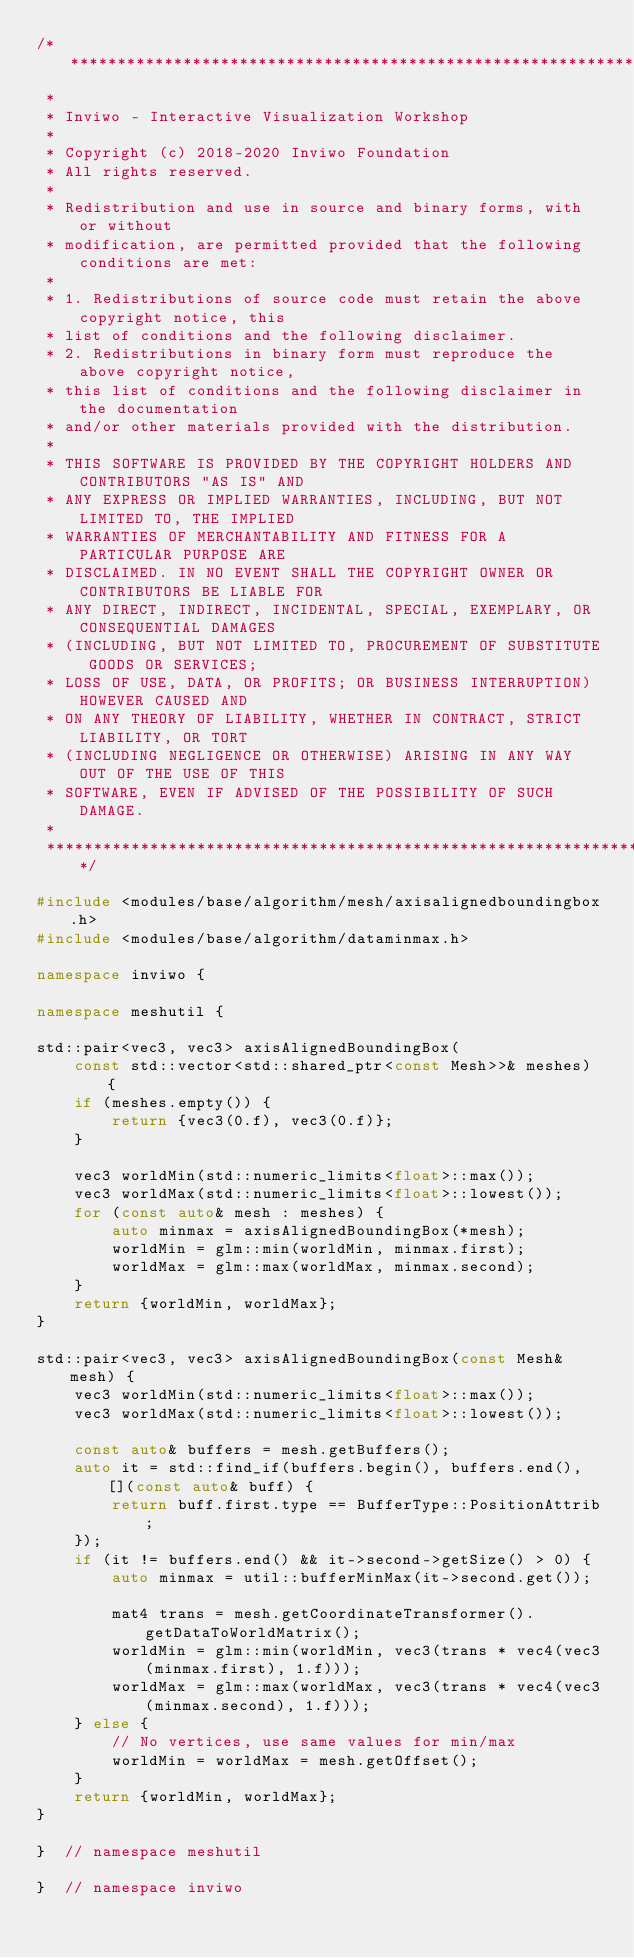<code> <loc_0><loc_0><loc_500><loc_500><_C++_>/*********************************************************************************
 *
 * Inviwo - Interactive Visualization Workshop
 *
 * Copyright (c) 2018-2020 Inviwo Foundation
 * All rights reserved.
 *
 * Redistribution and use in source and binary forms, with or without
 * modification, are permitted provided that the following conditions are met:
 *
 * 1. Redistributions of source code must retain the above copyright notice, this
 * list of conditions and the following disclaimer.
 * 2. Redistributions in binary form must reproduce the above copyright notice,
 * this list of conditions and the following disclaimer in the documentation
 * and/or other materials provided with the distribution.
 *
 * THIS SOFTWARE IS PROVIDED BY THE COPYRIGHT HOLDERS AND CONTRIBUTORS "AS IS" AND
 * ANY EXPRESS OR IMPLIED WARRANTIES, INCLUDING, BUT NOT LIMITED TO, THE IMPLIED
 * WARRANTIES OF MERCHANTABILITY AND FITNESS FOR A PARTICULAR PURPOSE ARE
 * DISCLAIMED. IN NO EVENT SHALL THE COPYRIGHT OWNER OR CONTRIBUTORS BE LIABLE FOR
 * ANY DIRECT, INDIRECT, INCIDENTAL, SPECIAL, EXEMPLARY, OR CONSEQUENTIAL DAMAGES
 * (INCLUDING, BUT NOT LIMITED TO, PROCUREMENT OF SUBSTITUTE GOODS OR SERVICES;
 * LOSS OF USE, DATA, OR PROFITS; OR BUSINESS INTERRUPTION) HOWEVER CAUSED AND
 * ON ANY THEORY OF LIABILITY, WHETHER IN CONTRACT, STRICT LIABILITY, OR TORT
 * (INCLUDING NEGLIGENCE OR OTHERWISE) ARISING IN ANY WAY OUT OF THE USE OF THIS
 * SOFTWARE, EVEN IF ADVISED OF THE POSSIBILITY OF SUCH DAMAGE.
 *
 *********************************************************************************/

#include <modules/base/algorithm/mesh/axisalignedboundingbox.h>
#include <modules/base/algorithm/dataminmax.h>

namespace inviwo {

namespace meshutil {

std::pair<vec3, vec3> axisAlignedBoundingBox(
    const std::vector<std::shared_ptr<const Mesh>>& meshes) {
    if (meshes.empty()) {
        return {vec3(0.f), vec3(0.f)};
    }

    vec3 worldMin(std::numeric_limits<float>::max());
    vec3 worldMax(std::numeric_limits<float>::lowest());
    for (const auto& mesh : meshes) {
        auto minmax = axisAlignedBoundingBox(*mesh);
        worldMin = glm::min(worldMin, minmax.first);
        worldMax = glm::max(worldMax, minmax.second);
    }
    return {worldMin, worldMax};
}

std::pair<vec3, vec3> axisAlignedBoundingBox(const Mesh& mesh) {
    vec3 worldMin(std::numeric_limits<float>::max());
    vec3 worldMax(std::numeric_limits<float>::lowest());

    const auto& buffers = mesh.getBuffers();
    auto it = std::find_if(buffers.begin(), buffers.end(), [](const auto& buff) {
        return buff.first.type == BufferType::PositionAttrib;
    });
    if (it != buffers.end() && it->second->getSize() > 0) {
        auto minmax = util::bufferMinMax(it->second.get());

        mat4 trans = mesh.getCoordinateTransformer().getDataToWorldMatrix();
        worldMin = glm::min(worldMin, vec3(trans * vec4(vec3(minmax.first), 1.f)));
        worldMax = glm::max(worldMax, vec3(trans * vec4(vec3(minmax.second), 1.f)));
    } else {
        // No vertices, use same values for min/max
        worldMin = worldMax = mesh.getOffset();
    }
    return {worldMin, worldMax};
}

}  // namespace meshutil

}  // namespace inviwo
</code> 